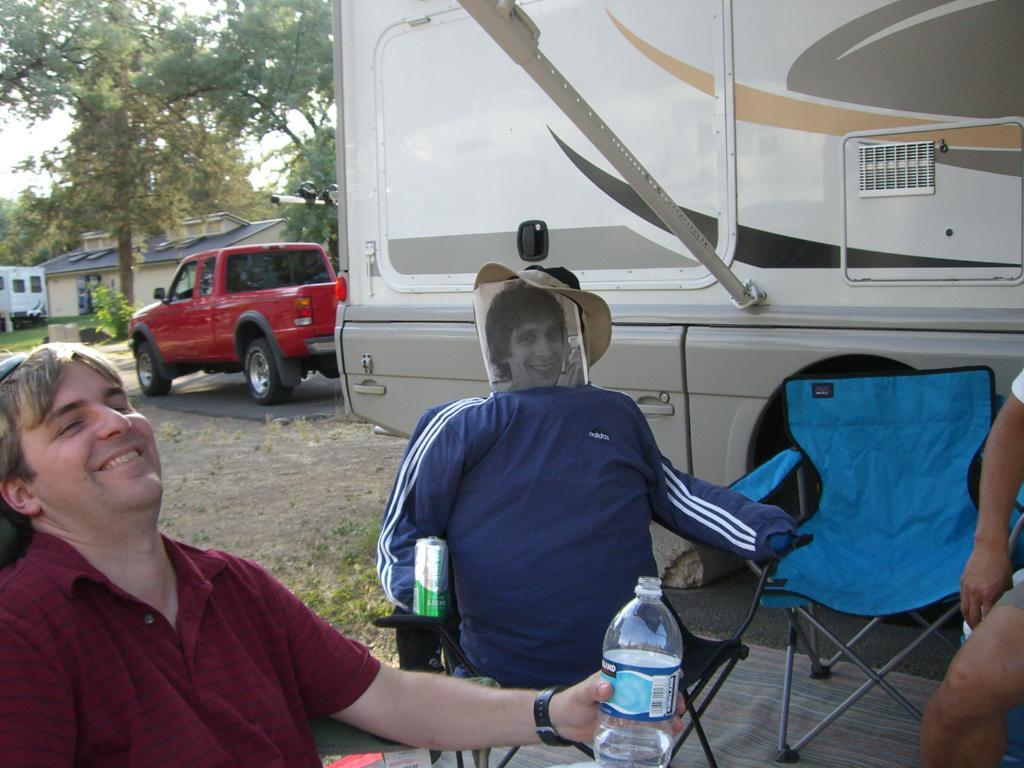Who is present in the image? There is a man in the image. What is the man doing in the image? The man is sitting on a chair and smiling. What is the man holding in the image? The man is holding a water bottle. What can be seen on the road in the image? There is a vehicle on the road in the image. What type of vegetation is visible in the image? There are trees in the image. Can you see a spoon being used by the kitten in the image? There is no kitten or spoon present in the image. Where is the nearest market to the location depicted in the image? The provided facts do not give any information about the location or the nearest market, so it cannot be determined from the image. 